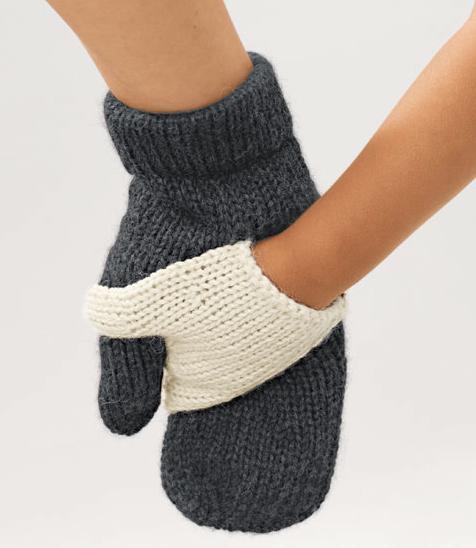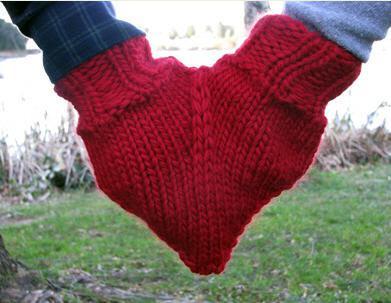The first image is the image on the left, the second image is the image on the right. Examine the images to the left and right. Is the description "An image shows a pair of hands in joined red mittens that form a heart shape when worn." accurate? Answer yes or no. Yes. The first image is the image on the left, the second image is the image on the right. Given the left and right images, does the statement "One of the images shows at least one pair of gloves without any hands in them." hold true? Answer yes or no. No. 